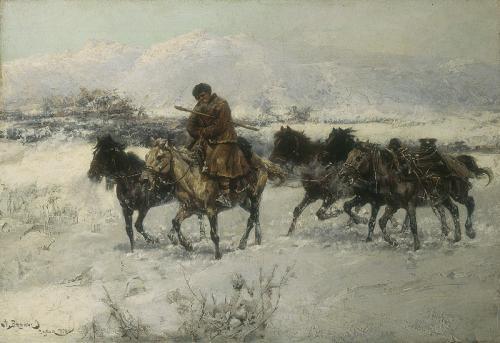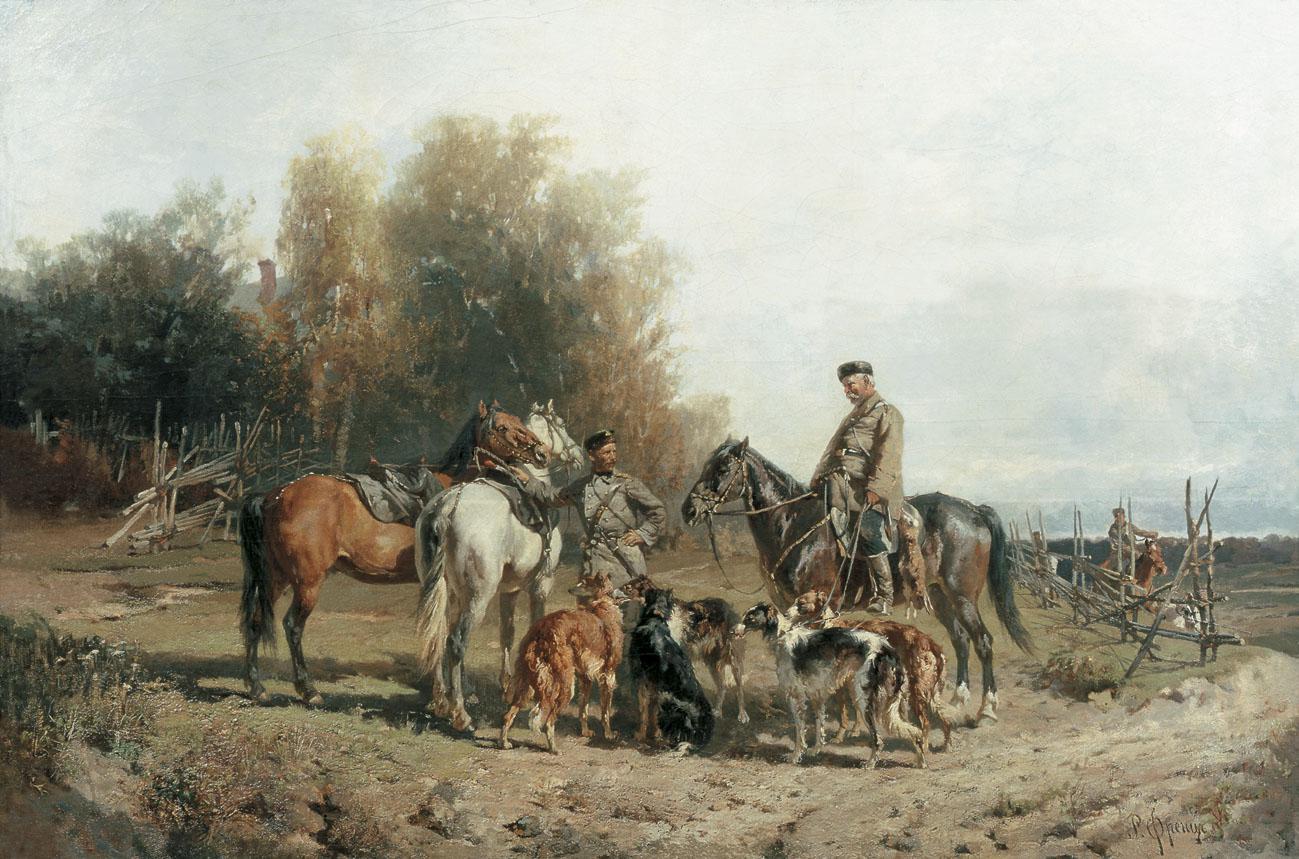The first image is the image on the left, the second image is the image on the right. Evaluate the accuracy of this statement regarding the images: "One image shows at least one man on a horse with at least two dogs standing next to the horse, and the other image shows horses but no wagon.". Is it true? Answer yes or no. Yes. 